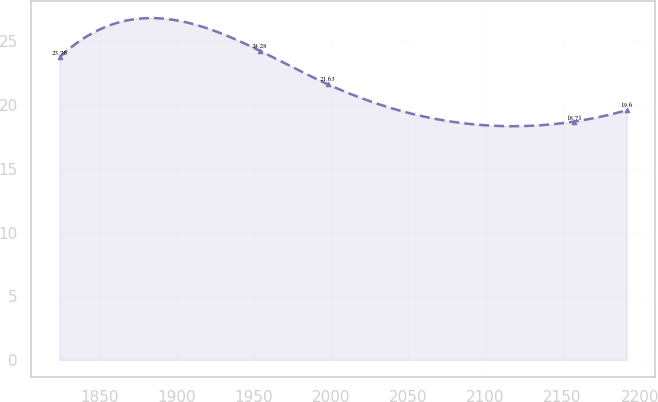Convert chart to OTSL. <chart><loc_0><loc_0><loc_500><loc_500><line_chart><ecel><fcel>Unnamed: 1<nl><fcel>1824.01<fcel>23.76<nl><fcel>1953.71<fcel>24.28<nl><fcel>1998.04<fcel>21.63<nl><fcel>2157.31<fcel>18.71<nl><fcel>2191.56<fcel>19.6<nl></chart> 